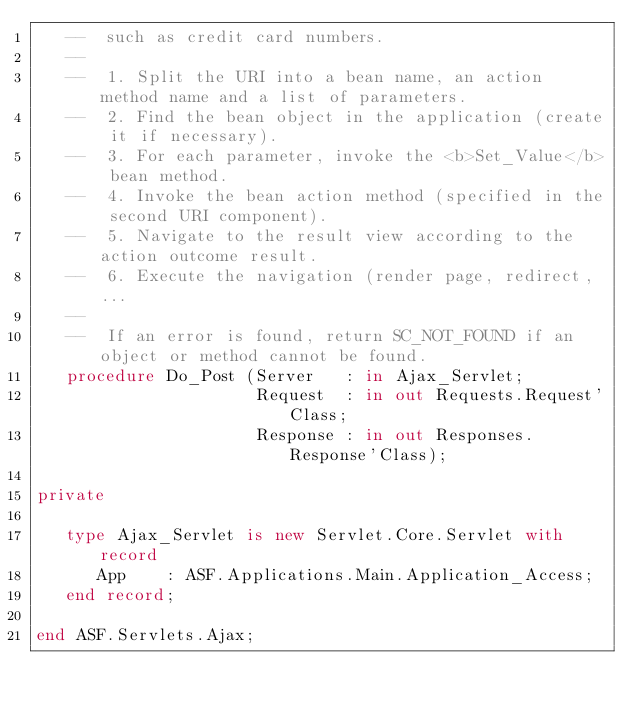Convert code to text. <code><loc_0><loc_0><loc_500><loc_500><_Ada_>   --  such as credit card numbers.
   --
   --  1. Split the URI into a bean name, an action method name and a list of parameters.
   --  2. Find the bean object in the application (create it if necessary).
   --  3. For each parameter, invoke the <b>Set_Value</b> bean method.
   --  4. Invoke the bean action method (specified in the second URI component).
   --  5. Navigate to the result view according to the action outcome result.
   --  6. Execute the navigation (render page, redirect, ...
   --
   --  If an error is found, return SC_NOT_FOUND if an object or method cannot be found.
   procedure Do_Post (Server   : in Ajax_Servlet;
                      Request  : in out Requests.Request'Class;
                      Response : in out Responses.Response'Class);

private

   type Ajax_Servlet is new Servlet.Core.Servlet with record
      App    : ASF.Applications.Main.Application_Access;
   end record;

end ASF.Servlets.Ajax;
</code> 